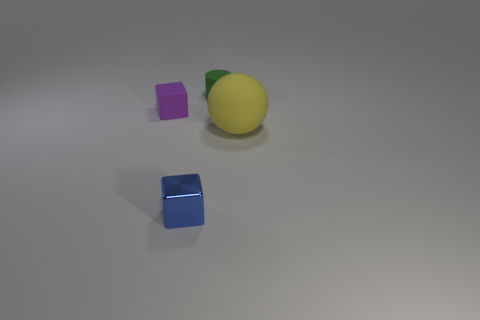What could be the possible material of the shiny yellow object and the cubes? The shiny yellow object has a smooth surface and appears to resemble a lemon, but considering the context and its sheen, it could be a plastic or metal representation rather than an organic lemon. The cubes, with their perfect edges and glossy surfaces, are likely made of a reflective material such as polished metal or acrylic, adding to the aesthetic value and drawing attention to their geometric precision.  Are there any indicators of the size of these objects? The image does not provide a clear reference for scale, such as a familiar object of known size or a measuring indicator. However, the objects display shadows and reflections that suggest they might be small to medium-sized, potentially small enough to be held in one hand. The exact dimensions remain indeterminate without additional context. 